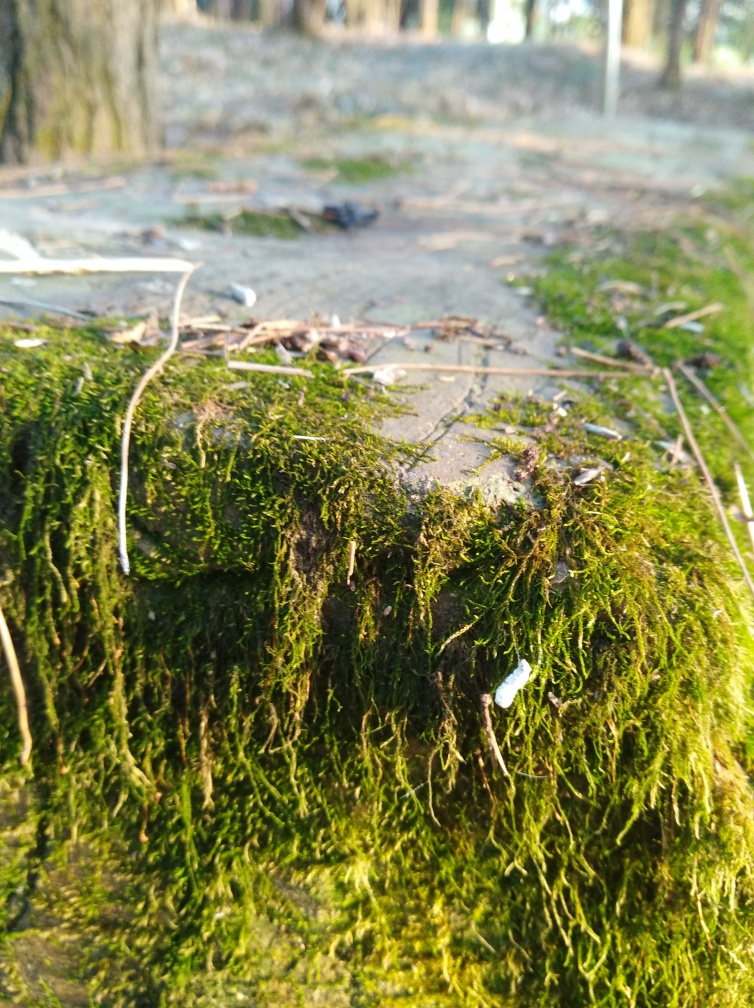Can you describe the ecosystem or habitat shown in the image? The image features a close-up of a mossy surface which suggests a moist, possibly woodland ecosystem. Such environments are typically characterized by a variety of plant species, including mosses, which thrive in damp conditions. The presence of fallen leaves and twigs hints at a forest floor or a similar natural setting rich in organic material. 